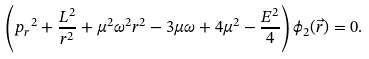<formula> <loc_0><loc_0><loc_500><loc_500>\left ( { p _ { r } } ^ { 2 } + \frac { L ^ { 2 } } { r ^ { 2 } } + \mu ^ { 2 } { \omega } ^ { 2 } r ^ { 2 } - 3 \mu \omega + 4 \mu ^ { 2 } - \frac { E ^ { 2 } } { 4 } \right ) { \phi } _ { 2 } ( \vec { r } ) = 0 .</formula> 